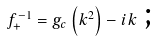<formula> <loc_0><loc_0><loc_500><loc_500>f _ { + } ^ { - 1 } = g _ { c } \left ( k ^ { 2 } \right ) - i k \text { ;}</formula> 